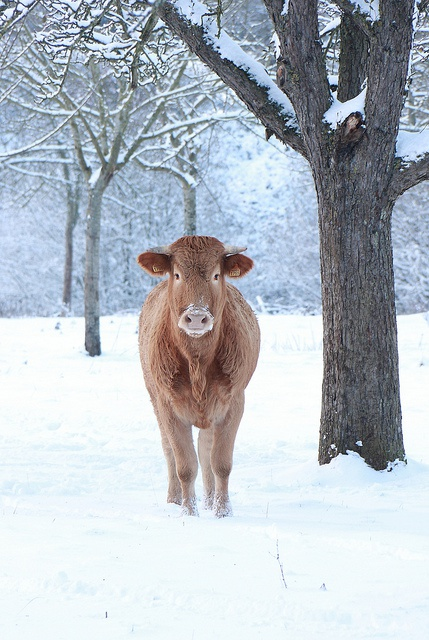Describe the objects in this image and their specific colors. I can see a cow in darkgray, gray, and brown tones in this image. 